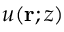<formula> <loc_0><loc_0><loc_500><loc_500>u ( r ; z )</formula> 